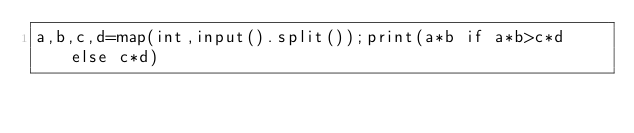Convert code to text. <code><loc_0><loc_0><loc_500><loc_500><_Python_>a,b,c,d=map(int,input().split());print(a*b if a*b>c*d else c*d)</code> 